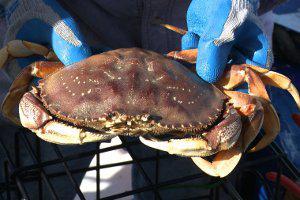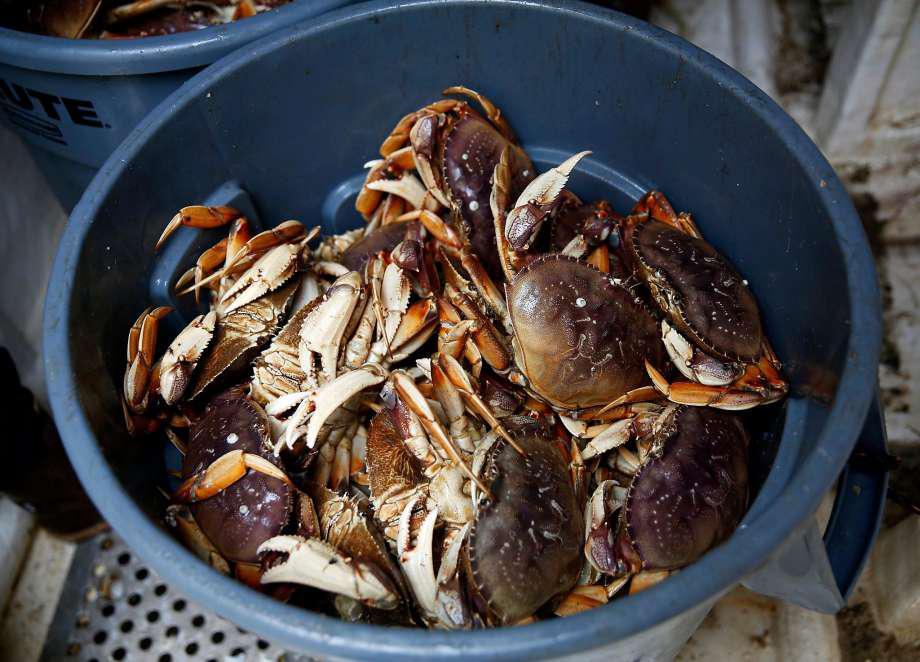The first image is the image on the left, the second image is the image on the right. Analyze the images presented: Is the assertion "All images include at least one forward-facing reddish-orange crab with its shell intact." valid? Answer yes or no. No. The first image is the image on the left, the second image is the image on the right. Analyze the images presented: Is the assertion "There is only one crab in at least one of the images." valid? Answer yes or no. Yes. 